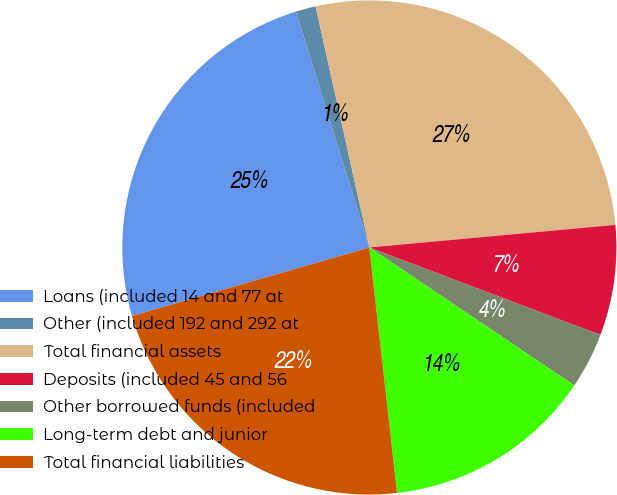Convert chart to OTSL. <chart><loc_0><loc_0><loc_500><loc_500><pie_chart><fcel>Loans (included 14 and 77 at<fcel>Other (included 192 and 292 at<fcel>Total financial assets<fcel>Deposits (included 45 and 56<fcel>Other borrowed funds (included<fcel>Long-term debt and junior<fcel>Total financial liabilities<nl><fcel>24.67%<fcel>1.31%<fcel>27.03%<fcel>7.22%<fcel>3.67%<fcel>13.78%<fcel>22.31%<nl></chart> 